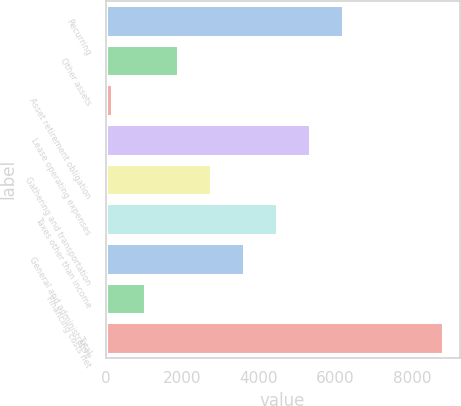Convert chart. <chart><loc_0><loc_0><loc_500><loc_500><bar_chart><fcel>Recurring<fcel>Other assets<fcel>Asset retirement obligation<fcel>Lease operating expenses<fcel>Gathering and transportation<fcel>Taxes other than income<fcel>General and administrative<fcel>Financing costs net<fcel>Total<nl><fcel>6202.7<fcel>1882.2<fcel>154<fcel>5338.6<fcel>2746.3<fcel>4474.5<fcel>3610.4<fcel>1018.1<fcel>8795<nl></chart> 